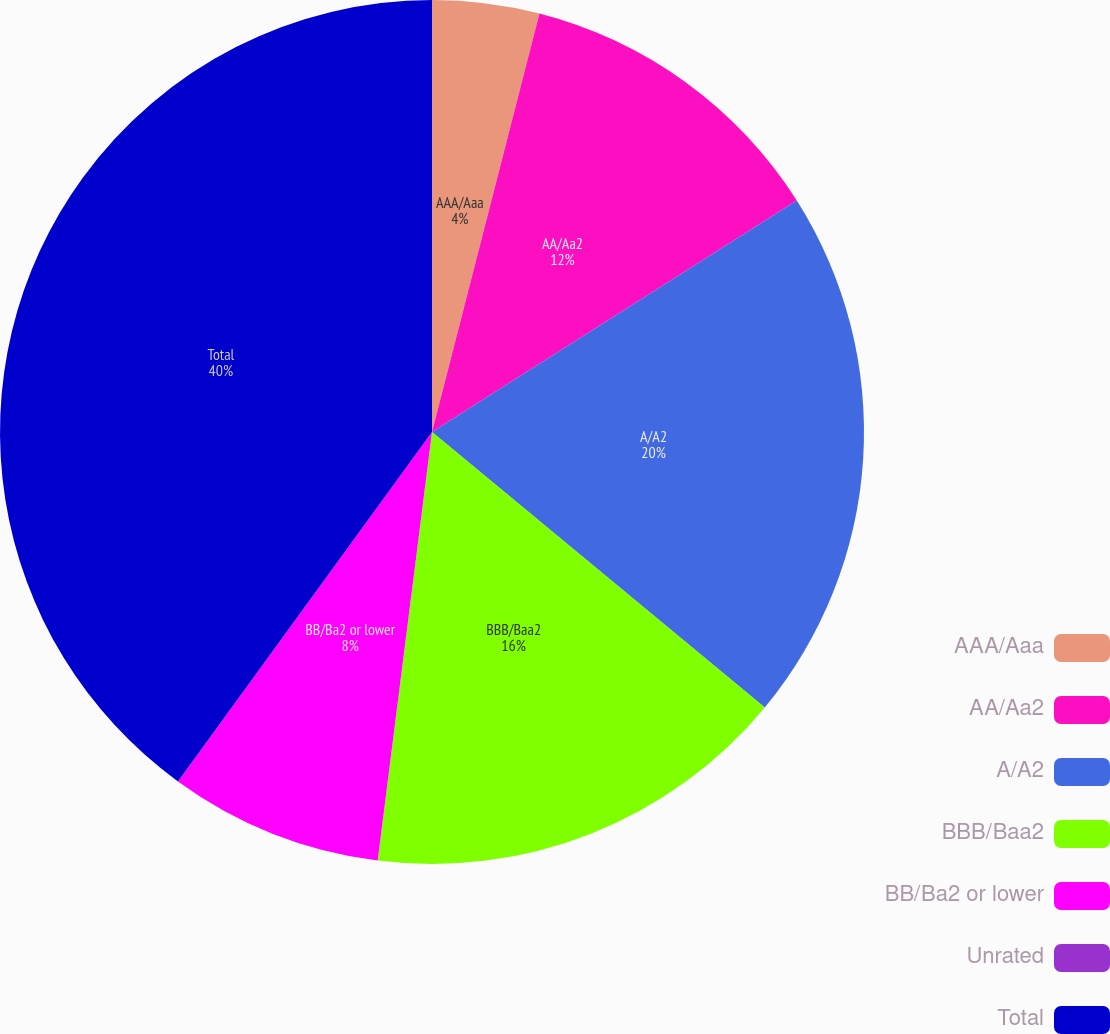<chart> <loc_0><loc_0><loc_500><loc_500><pie_chart><fcel>AAA/Aaa<fcel>AA/Aa2<fcel>A/A2<fcel>BBB/Baa2<fcel>BB/Ba2 or lower<fcel>Unrated<fcel>Total<nl><fcel>4.0%<fcel>12.0%<fcel>20.0%<fcel>16.0%<fcel>8.0%<fcel>0.0%<fcel>39.99%<nl></chart> 